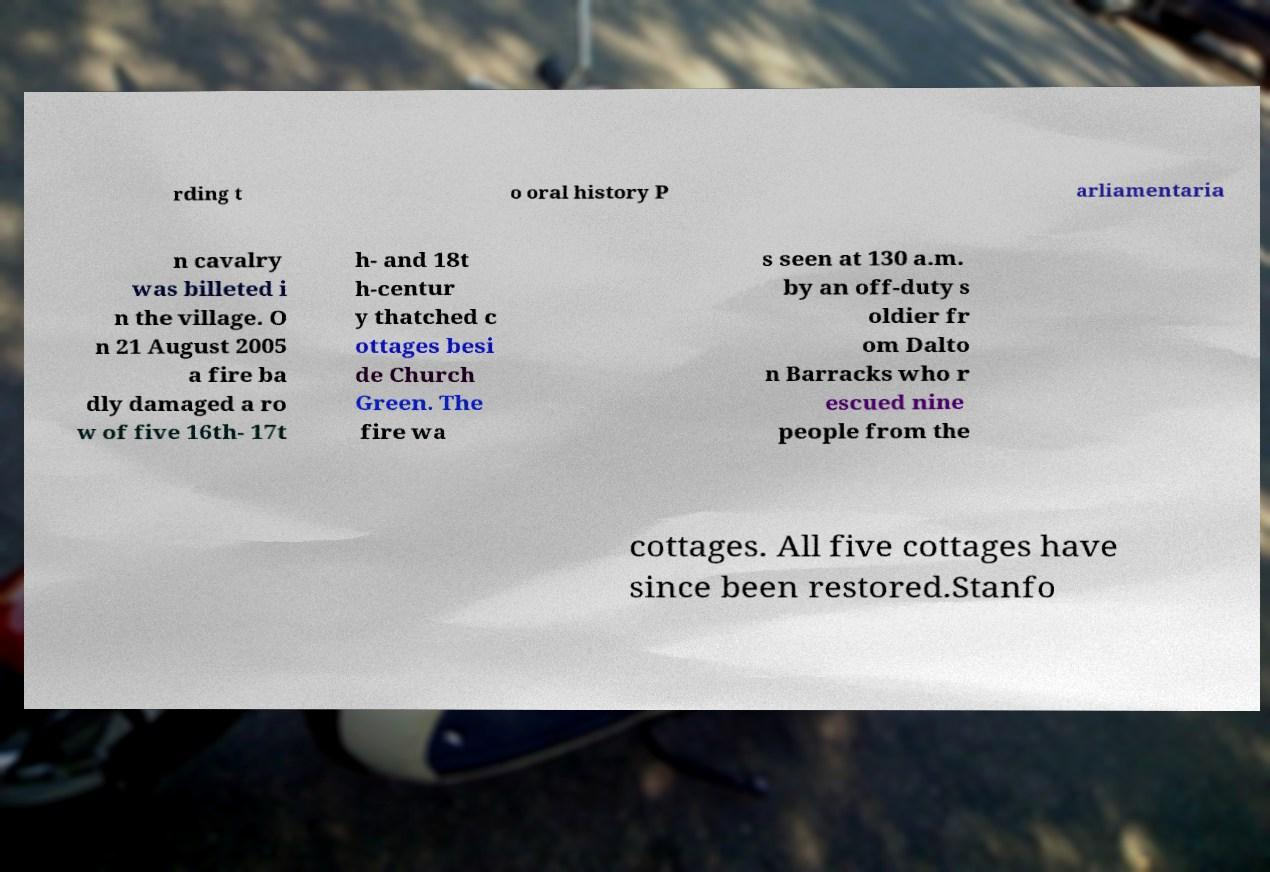There's text embedded in this image that I need extracted. Can you transcribe it verbatim? rding t o oral history P arliamentaria n cavalry was billeted i n the village. O n 21 August 2005 a fire ba dly damaged a ro w of five 16th- 17t h- and 18t h-centur y thatched c ottages besi de Church Green. The fire wa s seen at 130 a.m. by an off-duty s oldier fr om Dalto n Barracks who r escued nine people from the cottages. All five cottages have since been restored.Stanfo 